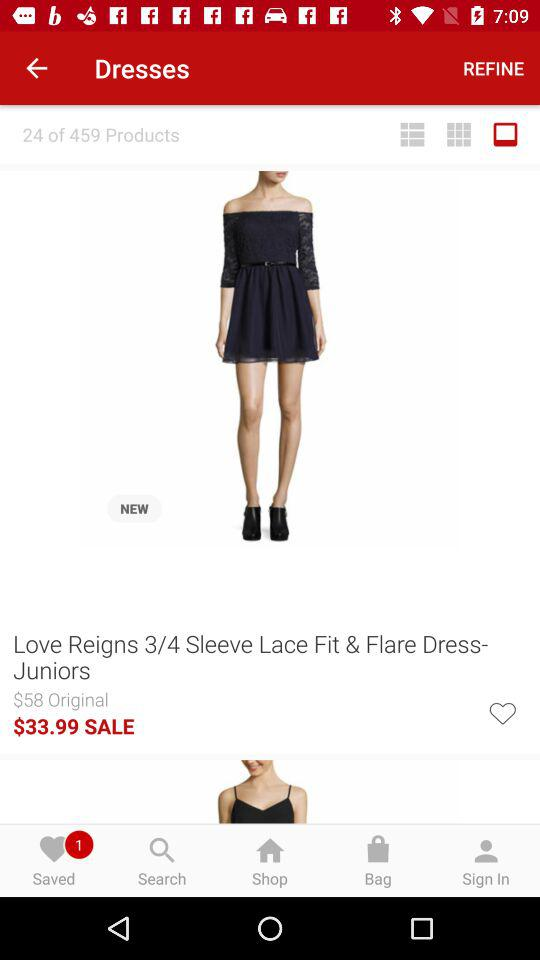What is the name of the dress? The name of the dress is "Love Reigns 3/4 Sleeve Lace Fit & Flare Dress- Juniors". 